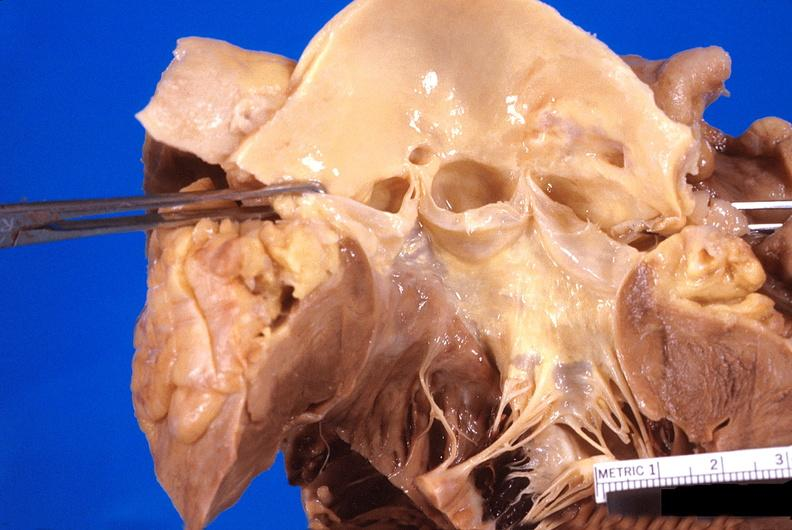s cardiovascular present?
Answer the question using a single word or phrase. Yes 